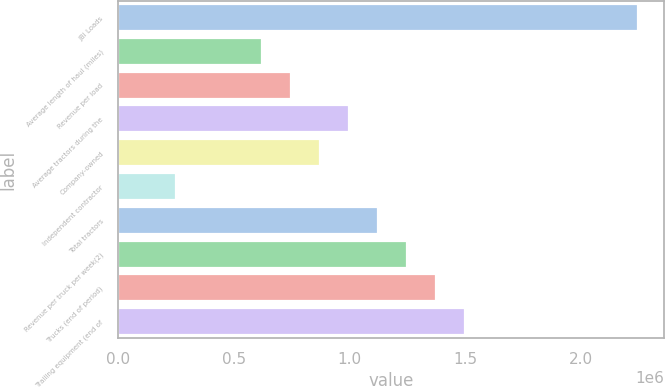Convert chart to OTSL. <chart><loc_0><loc_0><loc_500><loc_500><bar_chart><fcel>JBI Loads<fcel>Average length of haul (miles)<fcel>Revenue per load<fcel>Average tractors during the<fcel>Company-owned<fcel>Independent contractor<fcel>Total tractors<fcel>Revenue per truck per week(2)<fcel>Trucks (end of period)<fcel>Trailing equipment (end of<nl><fcel>2.24693e+06<fcel>624158<fcel>748987<fcel>998644<fcel>873815<fcel>249671<fcel>1.12347e+06<fcel>1.2483e+06<fcel>1.37313e+06<fcel>1.49796e+06<nl></chart> 